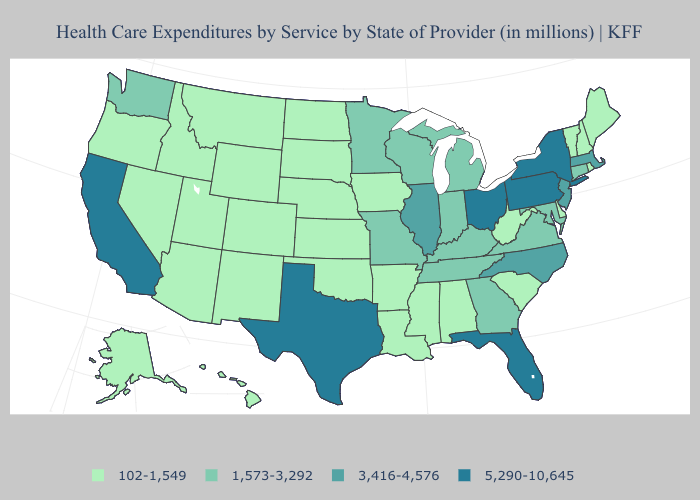Is the legend a continuous bar?
Concise answer only. No. Does the map have missing data?
Be succinct. No. Among the states that border Illinois , does Missouri have the highest value?
Short answer required. Yes. Among the states that border Idaho , which have the highest value?
Keep it brief. Washington. What is the value of Texas?
Write a very short answer. 5,290-10,645. Which states have the lowest value in the South?
Give a very brief answer. Alabama, Arkansas, Delaware, Louisiana, Mississippi, Oklahoma, South Carolina, West Virginia. Does the first symbol in the legend represent the smallest category?
Keep it brief. Yes. What is the value of Alaska?
Write a very short answer. 102-1,549. What is the value of Arizona?
Be succinct. 102-1,549. What is the value of Kentucky?
Keep it brief. 1,573-3,292. Does New Hampshire have a higher value than Minnesota?
Be succinct. No. What is the highest value in the USA?
Give a very brief answer. 5,290-10,645. Which states have the highest value in the USA?
Write a very short answer. California, Florida, New York, Ohio, Pennsylvania, Texas. What is the highest value in the Northeast ?
Give a very brief answer. 5,290-10,645. Name the states that have a value in the range 3,416-4,576?
Quick response, please. Illinois, Massachusetts, New Jersey, North Carolina. 